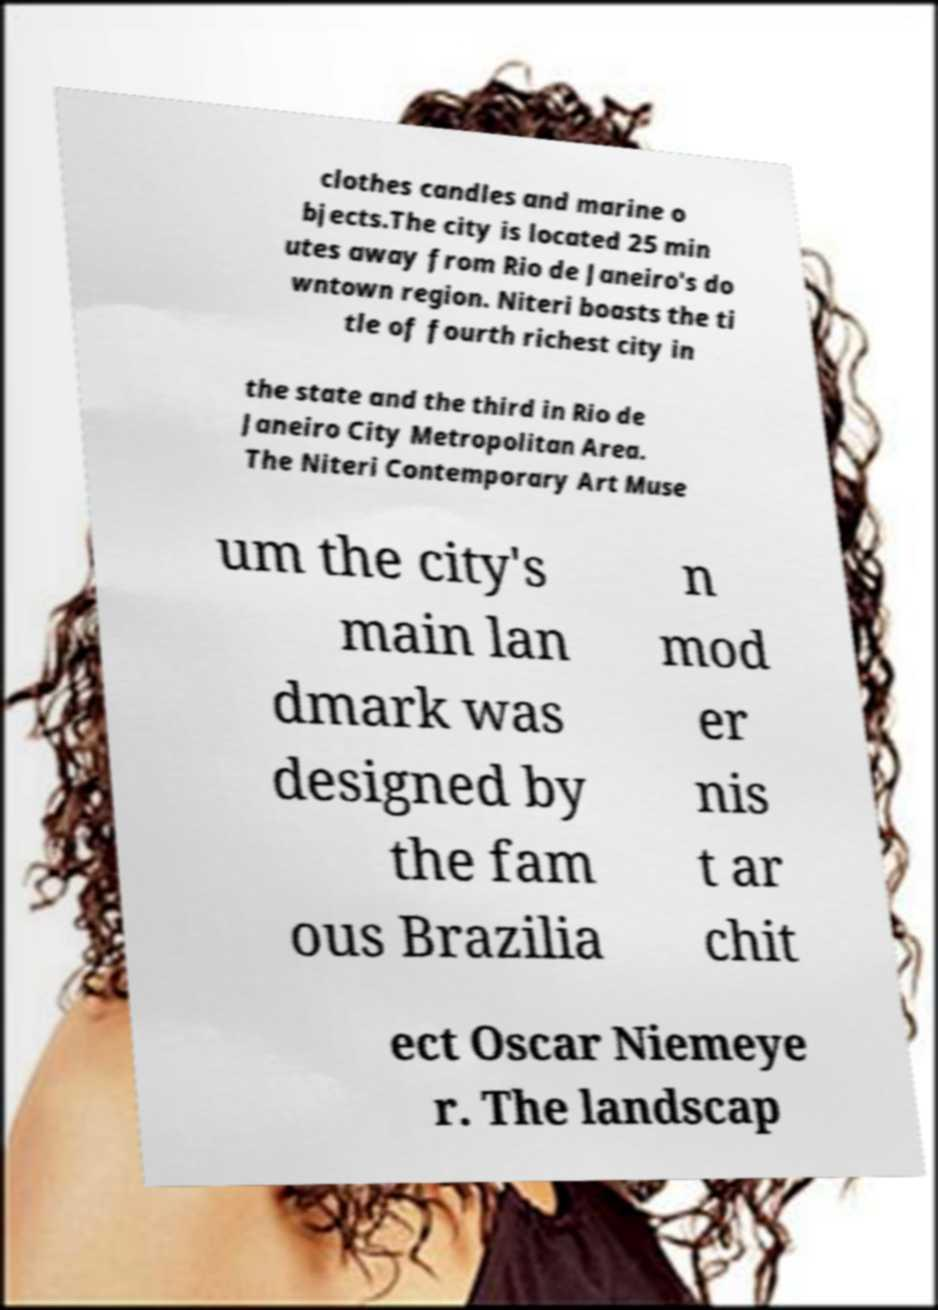What messages or text are displayed in this image? I need them in a readable, typed format. clothes candles and marine o bjects.The city is located 25 min utes away from Rio de Janeiro's do wntown region. Niteri boasts the ti tle of fourth richest city in the state and the third in Rio de Janeiro City Metropolitan Area. The Niteri Contemporary Art Muse um the city's main lan dmark was designed by the fam ous Brazilia n mod er nis t ar chit ect Oscar Niemeye r. The landscap 